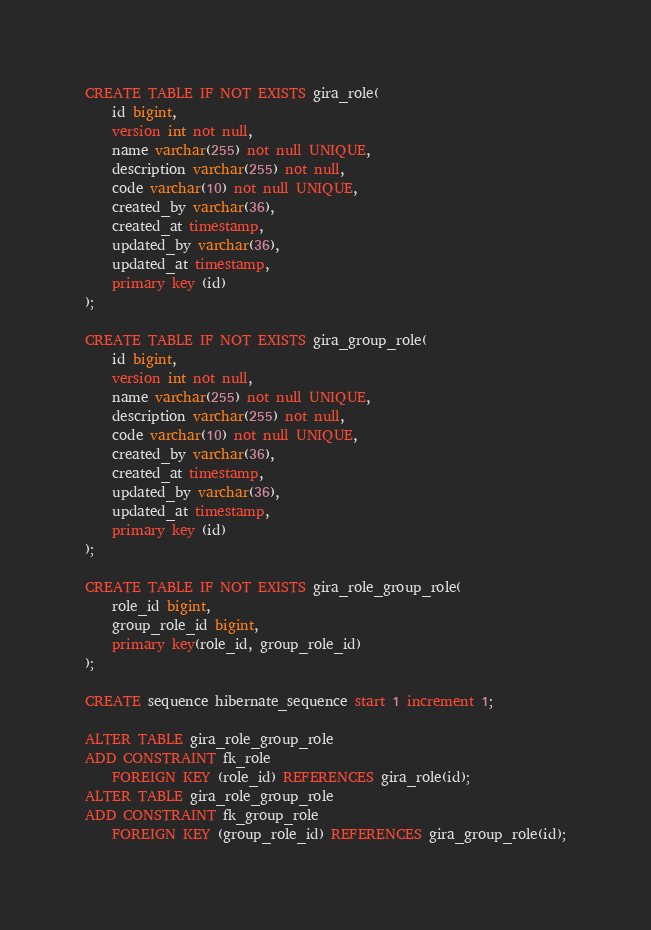<code> <loc_0><loc_0><loc_500><loc_500><_SQL_>CREATE TABLE IF NOT EXISTS gira_role(
	id bigint,
	version int not null,
	name varchar(255) not null UNIQUE,
	description varchar(255) not null,
	code varchar(10) not null UNIQUE,
	created_by varchar(36),
	created_at timestamp,
	updated_by varchar(36),
	updated_at timestamp,
	primary key (id)
);

CREATE TABLE IF NOT EXISTS gira_group_role(
	id bigint,
	version int not null,
	name varchar(255) not null UNIQUE,
	description varchar(255) not null,
	code varchar(10) not null UNIQUE,
	created_by varchar(36),
	created_at timestamp,
	updated_by varchar(36),
	updated_at timestamp,
	primary key (id)
);

CREATE TABLE IF NOT EXISTS gira_role_group_role(
	role_id bigint,
	group_role_id bigint,
	primary key(role_id, group_role_id)
);

CREATE sequence hibernate_sequence start 1 increment 1;

ALTER TABLE gira_role_group_role
ADD CONSTRAINT fk_role 
	FOREIGN KEY (role_id) REFERENCES gira_role(id);
ALTER TABLE gira_role_group_role
ADD CONSTRAINT fk_group_role
	FOREIGN KEY (group_role_id) REFERENCES gira_group_role(id);</code> 